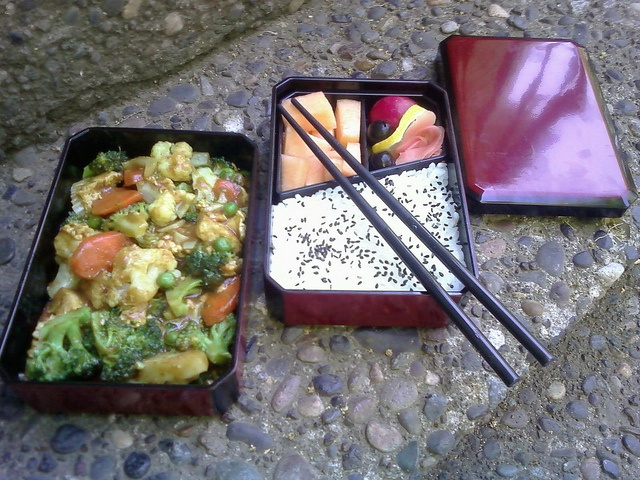Describe the objects in this image and their specific colors. I can see bowl in gray, black, and olive tones, bowl in gray, white, black, and maroon tones, broccoli in gray, green, black, darkgreen, and olive tones, broccoli in gray, olive, and darkgreen tones, and carrot in gray, brown, and salmon tones in this image. 